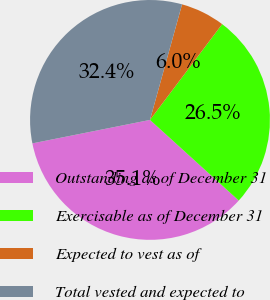Convert chart. <chart><loc_0><loc_0><loc_500><loc_500><pie_chart><fcel>Outstanding as of December 31<fcel>Exercisable as of December 31<fcel>Expected to vest as of<fcel>Total vested and expected to<nl><fcel>35.13%<fcel>26.46%<fcel>5.97%<fcel>32.44%<nl></chart> 